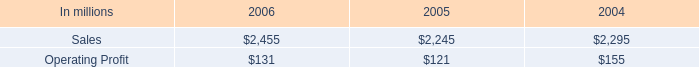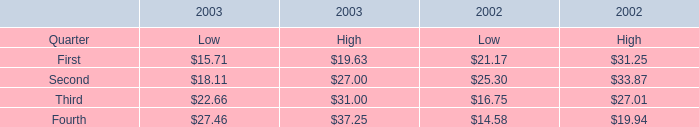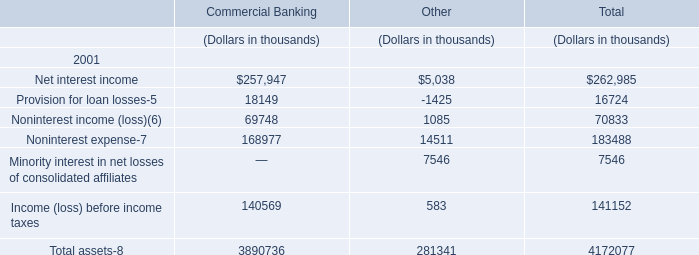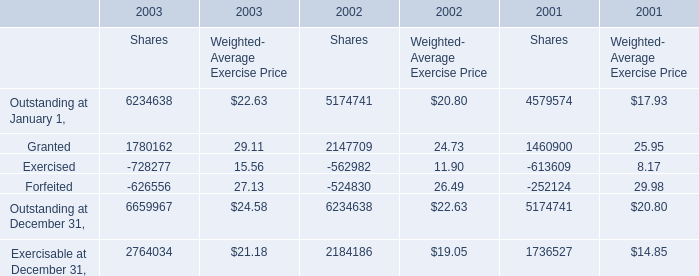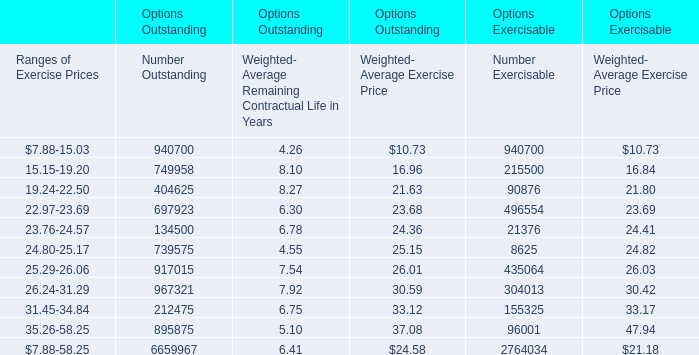What was the Weighted- Average Exercise Price for Ranges of Exercise Prices:23.76-24.57 in terms of Options Outstanding as As the chart 4 shows? 
Answer: 24.36. 